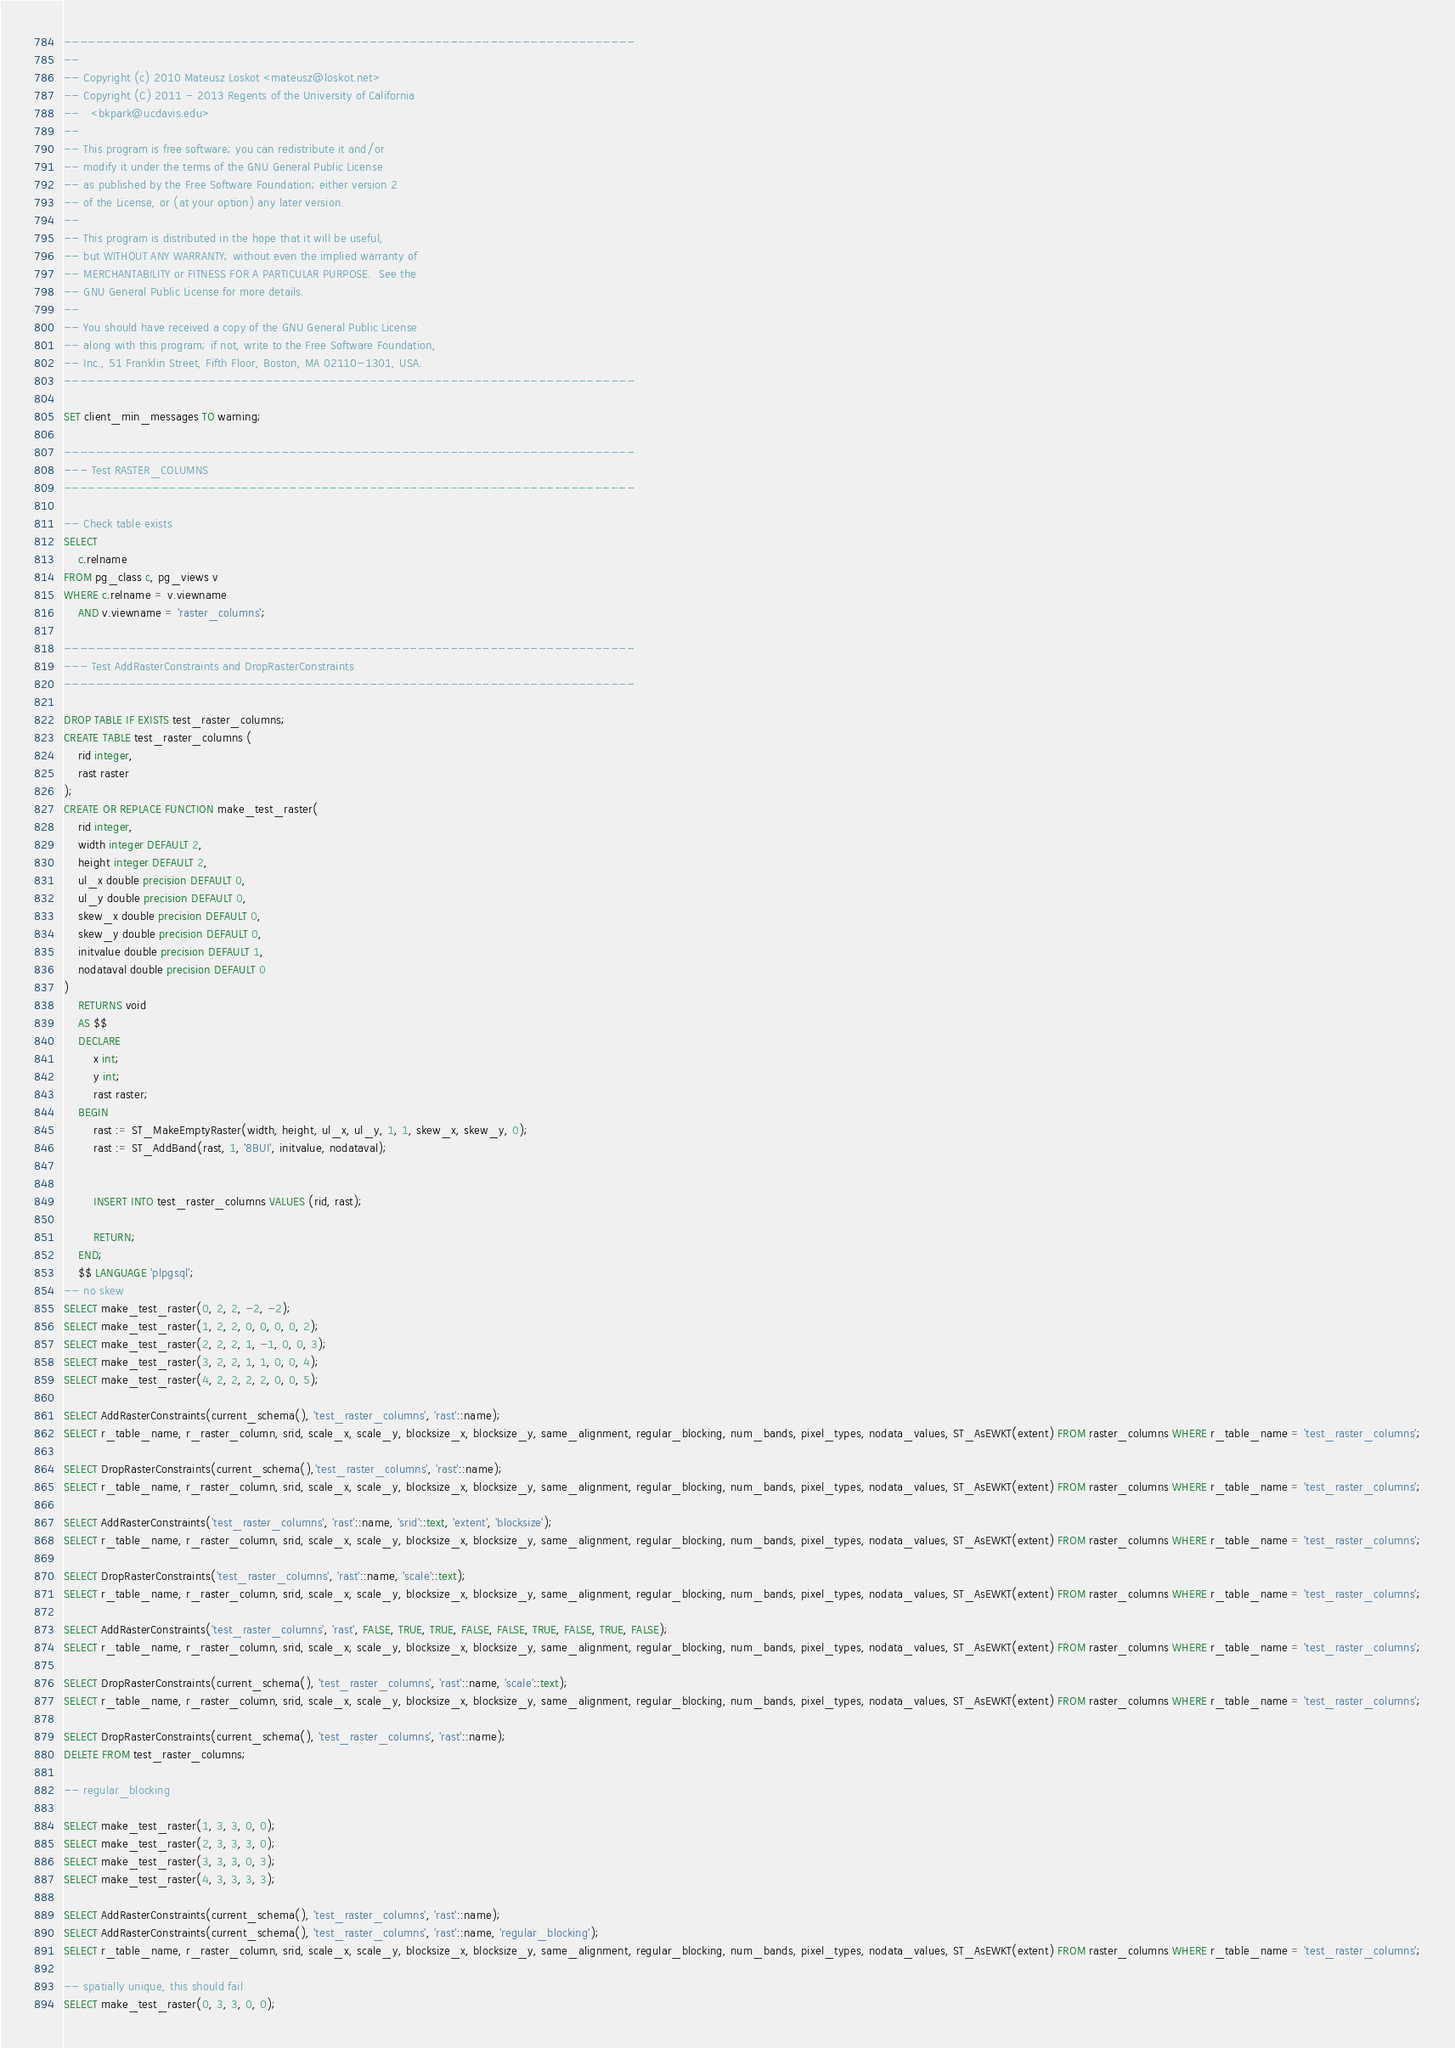Convert code to text. <code><loc_0><loc_0><loc_500><loc_500><_SQL_>-----------------------------------------------------------------------
--
-- Copyright (c) 2010 Mateusz Loskot <mateusz@loskot.net>
-- Copyright (C) 2011 - 2013 Regents of the University of California
--   <bkpark@ucdavis.edu>
--
-- This program is free software; you can redistribute it and/or
-- modify it under the terms of the GNU General Public License
-- as published by the Free Software Foundation; either version 2
-- of the License, or (at your option) any later version.
--
-- This program is distributed in the hope that it will be useful,
-- but WITHOUT ANY WARRANTY; without even the implied warranty of
-- MERCHANTABILITY or FITNESS FOR A PARTICULAR PURPOSE.  See the
-- GNU General Public License for more details.
--
-- You should have received a copy of the GNU General Public License
-- along with this program; if not, write to the Free Software Foundation,
-- Inc., 51 Franklin Street, Fifth Floor, Boston, MA 02110-1301, USA.
-----------------------------------------------------------------------

SET client_min_messages TO warning;

-----------------------------------------------------------------------
--- Test RASTER_COLUMNS
-----------------------------------------------------------------------

-- Check table exists
SELECT
	c.relname
FROM pg_class c, pg_views v
WHERE c.relname = v.viewname
	AND v.viewname = 'raster_columns';

-----------------------------------------------------------------------
--- Test AddRasterConstraints and DropRasterConstraints
-----------------------------------------------------------------------

DROP TABLE IF EXISTS test_raster_columns;
CREATE TABLE test_raster_columns (
	rid integer,
	rast raster
);
CREATE OR REPLACE FUNCTION make_test_raster(
	rid integer,
	width integer DEFAULT 2,
	height integer DEFAULT 2,
	ul_x double precision DEFAULT 0,
	ul_y double precision DEFAULT 0,
	skew_x double precision DEFAULT 0,
	skew_y double precision DEFAULT 0,
	initvalue double precision DEFAULT 1,
	nodataval double precision DEFAULT 0
)
	RETURNS void
	AS $$
	DECLARE
		x int;
		y int;
		rast raster;
	BEGIN
		rast := ST_MakeEmptyRaster(width, height, ul_x, ul_y, 1, 1, skew_x, skew_y, 0);
		rast := ST_AddBand(rast, 1, '8BUI', initvalue, nodataval);


		INSERT INTO test_raster_columns VALUES (rid, rast);

		RETURN;
	END;
	$$ LANGUAGE 'plpgsql';
-- no skew
SELECT make_test_raster(0, 2, 2, -2, -2);
SELECT make_test_raster(1, 2, 2, 0, 0, 0, 0, 2);
SELECT make_test_raster(2, 2, 2, 1, -1, 0, 0, 3);
SELECT make_test_raster(3, 2, 2, 1, 1, 0, 0, 4);
SELECT make_test_raster(4, 2, 2, 2, 2, 0, 0, 5);

SELECT AddRasterConstraints(current_schema(), 'test_raster_columns', 'rast'::name);
SELECT r_table_name, r_raster_column, srid, scale_x, scale_y, blocksize_x, blocksize_y, same_alignment, regular_blocking, num_bands, pixel_types, nodata_values, ST_AsEWKT(extent) FROM raster_columns WHERE r_table_name = 'test_raster_columns';

SELECT DropRasterConstraints(current_schema(),'test_raster_columns', 'rast'::name);
SELECT r_table_name, r_raster_column, srid, scale_x, scale_y, blocksize_x, blocksize_y, same_alignment, regular_blocking, num_bands, pixel_types, nodata_values, ST_AsEWKT(extent) FROM raster_columns WHERE r_table_name = 'test_raster_columns';

SELECT AddRasterConstraints('test_raster_columns', 'rast'::name, 'srid'::text, 'extent', 'blocksize');
SELECT r_table_name, r_raster_column, srid, scale_x, scale_y, blocksize_x, blocksize_y, same_alignment, regular_blocking, num_bands, pixel_types, nodata_values, ST_AsEWKT(extent) FROM raster_columns WHERE r_table_name = 'test_raster_columns';

SELECT DropRasterConstraints('test_raster_columns', 'rast'::name, 'scale'::text);
SELECT r_table_name, r_raster_column, srid, scale_x, scale_y, blocksize_x, blocksize_y, same_alignment, regular_blocking, num_bands, pixel_types, nodata_values, ST_AsEWKT(extent) FROM raster_columns WHERE r_table_name = 'test_raster_columns';

SELECT AddRasterConstraints('test_raster_columns', 'rast', FALSE, TRUE, TRUE, FALSE, FALSE, TRUE, FALSE, TRUE, FALSE);
SELECT r_table_name, r_raster_column, srid, scale_x, scale_y, blocksize_x, blocksize_y, same_alignment, regular_blocking, num_bands, pixel_types, nodata_values, ST_AsEWKT(extent) FROM raster_columns WHERE r_table_name = 'test_raster_columns';

SELECT DropRasterConstraints(current_schema(), 'test_raster_columns', 'rast'::name, 'scale'::text);
SELECT r_table_name, r_raster_column, srid, scale_x, scale_y, blocksize_x, blocksize_y, same_alignment, regular_blocking, num_bands, pixel_types, nodata_values, ST_AsEWKT(extent) FROM raster_columns WHERE r_table_name = 'test_raster_columns';

SELECT DropRasterConstraints(current_schema(), 'test_raster_columns', 'rast'::name);
DELETE FROM test_raster_columns;

-- regular_blocking

SELECT make_test_raster(1, 3, 3, 0, 0);
SELECT make_test_raster(2, 3, 3, 3, 0);
SELECT make_test_raster(3, 3, 3, 0, 3);
SELECT make_test_raster(4, 3, 3, 3, 3);

SELECT AddRasterConstraints(current_schema(), 'test_raster_columns', 'rast'::name);
SELECT AddRasterConstraints(current_schema(), 'test_raster_columns', 'rast'::name, 'regular_blocking');
SELECT r_table_name, r_raster_column, srid, scale_x, scale_y, blocksize_x, blocksize_y, same_alignment, regular_blocking, num_bands, pixel_types, nodata_values, ST_AsEWKT(extent) FROM raster_columns WHERE r_table_name = 'test_raster_columns';

-- spatially unique, this should fail 
SELECT make_test_raster(0, 3, 3, 0, 0);
</code> 